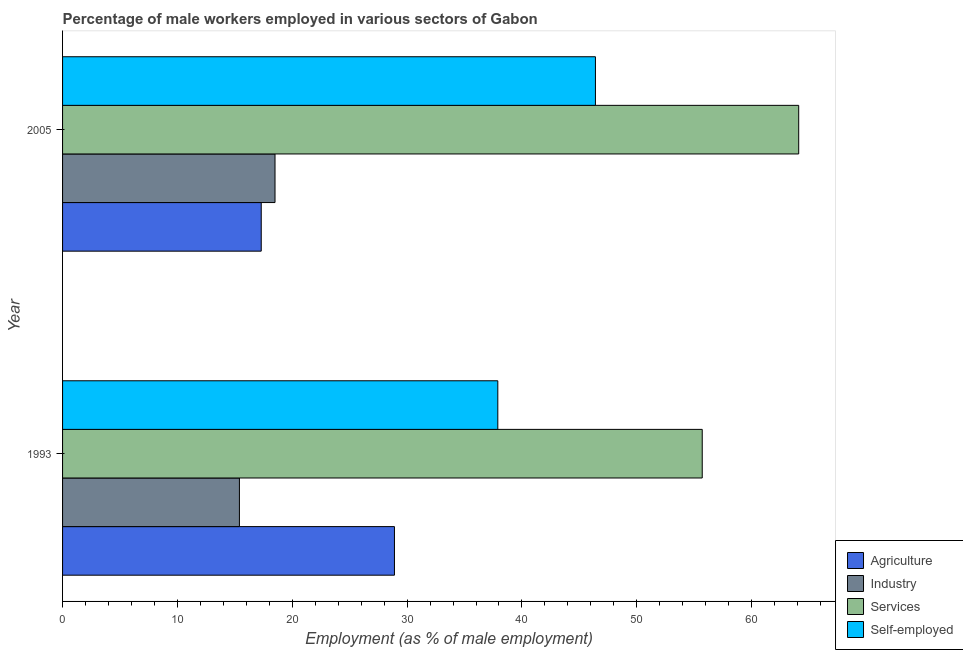How many different coloured bars are there?
Provide a succinct answer. 4. Are the number of bars on each tick of the Y-axis equal?
Provide a short and direct response. Yes. What is the label of the 2nd group of bars from the top?
Provide a succinct answer. 1993. In how many cases, is the number of bars for a given year not equal to the number of legend labels?
Provide a succinct answer. 0. What is the percentage of male workers in services in 2005?
Your answer should be very brief. 64.1. Across all years, what is the maximum percentage of self employed male workers?
Keep it short and to the point. 46.4. Across all years, what is the minimum percentage of male workers in industry?
Your answer should be very brief. 15.4. In which year was the percentage of male workers in agriculture minimum?
Your answer should be compact. 2005. What is the total percentage of self employed male workers in the graph?
Provide a short and direct response. 84.3. What is the difference between the percentage of male workers in agriculture in 1993 and that in 2005?
Ensure brevity in your answer.  11.6. What is the difference between the percentage of male workers in services in 2005 and the percentage of male workers in agriculture in 1993?
Provide a succinct answer. 35.2. What is the average percentage of male workers in agriculture per year?
Make the answer very short. 23.1. In how many years, is the percentage of male workers in agriculture greater than 34 %?
Offer a very short reply. 0. What is the ratio of the percentage of male workers in industry in 1993 to that in 2005?
Offer a very short reply. 0.83. Is the percentage of male workers in services in 1993 less than that in 2005?
Your response must be concise. Yes. Is the difference between the percentage of male workers in agriculture in 1993 and 2005 greater than the difference between the percentage of self employed male workers in 1993 and 2005?
Your response must be concise. Yes. What does the 2nd bar from the top in 2005 represents?
Your answer should be compact. Services. What does the 2nd bar from the bottom in 2005 represents?
Provide a succinct answer. Industry. How many bars are there?
Provide a succinct answer. 8. Are all the bars in the graph horizontal?
Offer a very short reply. Yes. Are the values on the major ticks of X-axis written in scientific E-notation?
Your answer should be very brief. No. Does the graph contain any zero values?
Your response must be concise. No. Does the graph contain grids?
Your response must be concise. No. Where does the legend appear in the graph?
Make the answer very short. Bottom right. How are the legend labels stacked?
Make the answer very short. Vertical. What is the title of the graph?
Make the answer very short. Percentage of male workers employed in various sectors of Gabon. Does "Australia" appear as one of the legend labels in the graph?
Keep it short and to the point. No. What is the label or title of the X-axis?
Your answer should be very brief. Employment (as % of male employment). What is the Employment (as % of male employment) of Agriculture in 1993?
Give a very brief answer. 28.9. What is the Employment (as % of male employment) in Industry in 1993?
Offer a terse response. 15.4. What is the Employment (as % of male employment) of Services in 1993?
Offer a terse response. 55.7. What is the Employment (as % of male employment) in Self-employed in 1993?
Your answer should be very brief. 37.9. What is the Employment (as % of male employment) of Agriculture in 2005?
Ensure brevity in your answer.  17.3. What is the Employment (as % of male employment) in Services in 2005?
Offer a very short reply. 64.1. What is the Employment (as % of male employment) of Self-employed in 2005?
Provide a short and direct response. 46.4. Across all years, what is the maximum Employment (as % of male employment) in Agriculture?
Your response must be concise. 28.9. Across all years, what is the maximum Employment (as % of male employment) in Industry?
Offer a terse response. 18.5. Across all years, what is the maximum Employment (as % of male employment) of Services?
Your response must be concise. 64.1. Across all years, what is the maximum Employment (as % of male employment) of Self-employed?
Ensure brevity in your answer.  46.4. Across all years, what is the minimum Employment (as % of male employment) in Agriculture?
Provide a succinct answer. 17.3. Across all years, what is the minimum Employment (as % of male employment) of Industry?
Provide a short and direct response. 15.4. Across all years, what is the minimum Employment (as % of male employment) in Services?
Keep it short and to the point. 55.7. Across all years, what is the minimum Employment (as % of male employment) in Self-employed?
Offer a very short reply. 37.9. What is the total Employment (as % of male employment) of Agriculture in the graph?
Provide a short and direct response. 46.2. What is the total Employment (as % of male employment) of Industry in the graph?
Make the answer very short. 33.9. What is the total Employment (as % of male employment) in Services in the graph?
Your answer should be very brief. 119.8. What is the total Employment (as % of male employment) of Self-employed in the graph?
Offer a terse response. 84.3. What is the difference between the Employment (as % of male employment) in Agriculture in 1993 and that in 2005?
Your response must be concise. 11.6. What is the difference between the Employment (as % of male employment) in Industry in 1993 and that in 2005?
Keep it short and to the point. -3.1. What is the difference between the Employment (as % of male employment) in Self-employed in 1993 and that in 2005?
Offer a terse response. -8.5. What is the difference between the Employment (as % of male employment) in Agriculture in 1993 and the Employment (as % of male employment) in Services in 2005?
Keep it short and to the point. -35.2. What is the difference between the Employment (as % of male employment) in Agriculture in 1993 and the Employment (as % of male employment) in Self-employed in 2005?
Your response must be concise. -17.5. What is the difference between the Employment (as % of male employment) of Industry in 1993 and the Employment (as % of male employment) of Services in 2005?
Offer a very short reply. -48.7. What is the difference between the Employment (as % of male employment) in Industry in 1993 and the Employment (as % of male employment) in Self-employed in 2005?
Your answer should be very brief. -31. What is the difference between the Employment (as % of male employment) of Services in 1993 and the Employment (as % of male employment) of Self-employed in 2005?
Provide a short and direct response. 9.3. What is the average Employment (as % of male employment) in Agriculture per year?
Keep it short and to the point. 23.1. What is the average Employment (as % of male employment) of Industry per year?
Offer a terse response. 16.95. What is the average Employment (as % of male employment) of Services per year?
Provide a succinct answer. 59.9. What is the average Employment (as % of male employment) in Self-employed per year?
Offer a terse response. 42.15. In the year 1993, what is the difference between the Employment (as % of male employment) in Agriculture and Employment (as % of male employment) in Services?
Your answer should be very brief. -26.8. In the year 1993, what is the difference between the Employment (as % of male employment) of Agriculture and Employment (as % of male employment) of Self-employed?
Your answer should be compact. -9. In the year 1993, what is the difference between the Employment (as % of male employment) of Industry and Employment (as % of male employment) of Services?
Keep it short and to the point. -40.3. In the year 1993, what is the difference between the Employment (as % of male employment) of Industry and Employment (as % of male employment) of Self-employed?
Your answer should be very brief. -22.5. In the year 1993, what is the difference between the Employment (as % of male employment) of Services and Employment (as % of male employment) of Self-employed?
Your answer should be compact. 17.8. In the year 2005, what is the difference between the Employment (as % of male employment) in Agriculture and Employment (as % of male employment) in Services?
Offer a very short reply. -46.8. In the year 2005, what is the difference between the Employment (as % of male employment) in Agriculture and Employment (as % of male employment) in Self-employed?
Offer a terse response. -29.1. In the year 2005, what is the difference between the Employment (as % of male employment) of Industry and Employment (as % of male employment) of Services?
Your answer should be compact. -45.6. In the year 2005, what is the difference between the Employment (as % of male employment) in Industry and Employment (as % of male employment) in Self-employed?
Offer a terse response. -27.9. In the year 2005, what is the difference between the Employment (as % of male employment) of Services and Employment (as % of male employment) of Self-employed?
Your answer should be compact. 17.7. What is the ratio of the Employment (as % of male employment) of Agriculture in 1993 to that in 2005?
Your answer should be compact. 1.67. What is the ratio of the Employment (as % of male employment) of Industry in 1993 to that in 2005?
Offer a very short reply. 0.83. What is the ratio of the Employment (as % of male employment) of Services in 1993 to that in 2005?
Keep it short and to the point. 0.87. What is the ratio of the Employment (as % of male employment) of Self-employed in 1993 to that in 2005?
Give a very brief answer. 0.82. What is the difference between the highest and the second highest Employment (as % of male employment) of Agriculture?
Give a very brief answer. 11.6. What is the difference between the highest and the second highest Employment (as % of male employment) in Industry?
Provide a short and direct response. 3.1. What is the difference between the highest and the second highest Employment (as % of male employment) of Services?
Make the answer very short. 8.4. What is the difference between the highest and the lowest Employment (as % of male employment) in Services?
Your response must be concise. 8.4. What is the difference between the highest and the lowest Employment (as % of male employment) of Self-employed?
Provide a succinct answer. 8.5. 